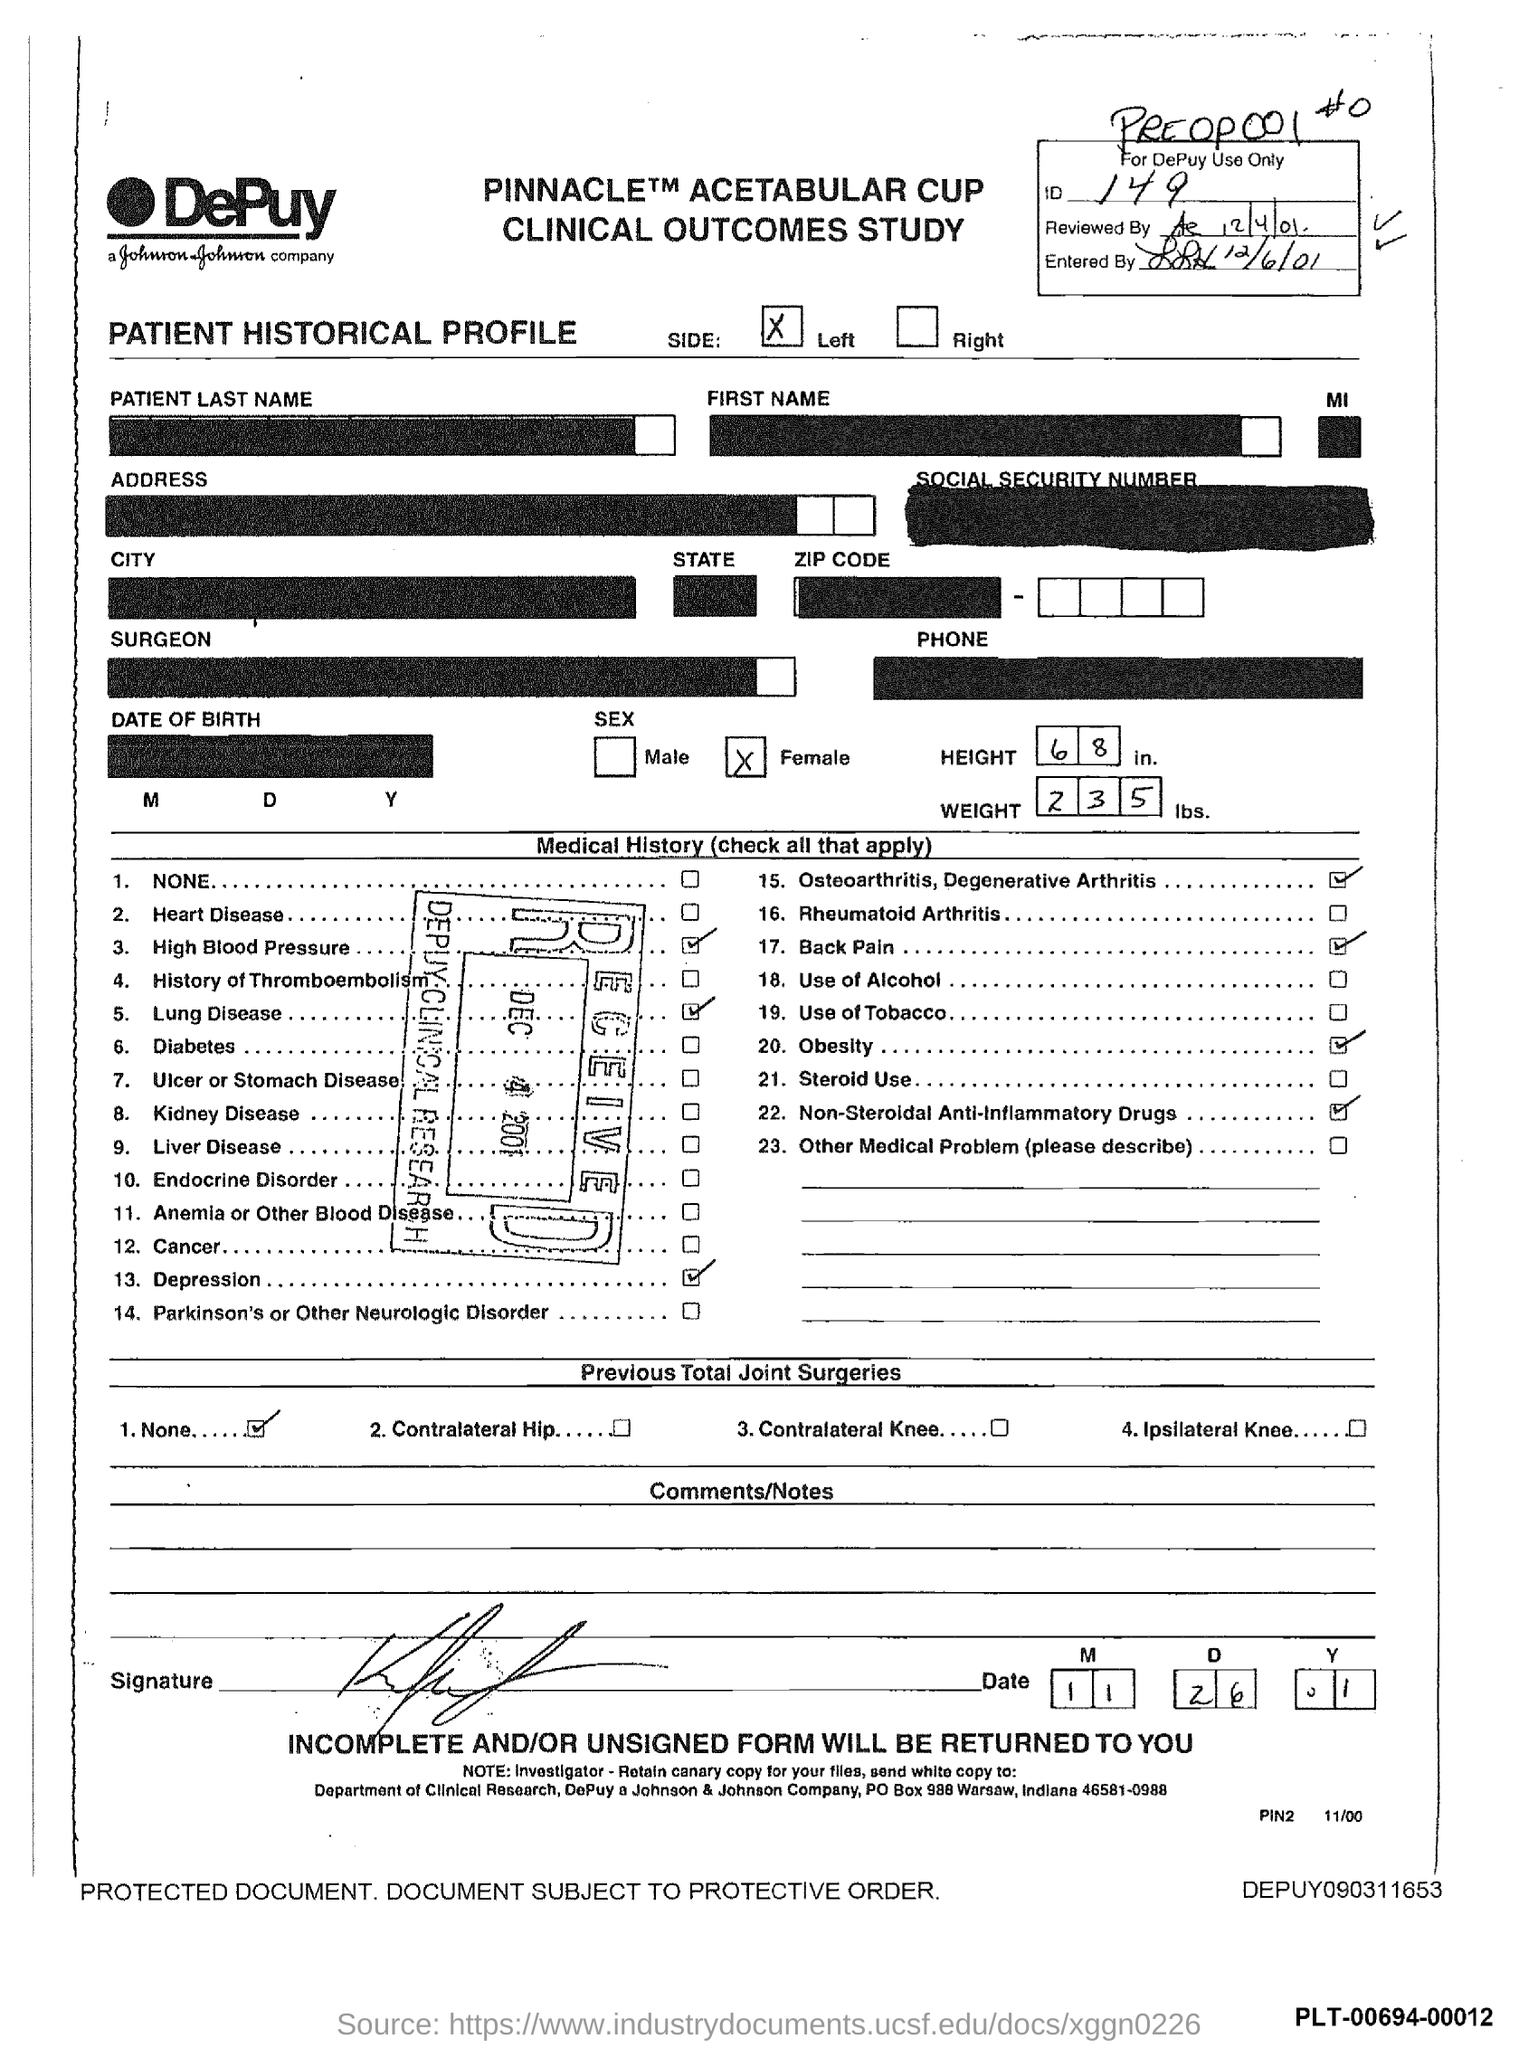What is the ID number?
Provide a short and direct response. 149. What is the reviewed date?
Provide a succinct answer. 12/4/01. What is the height of the patient?
Offer a terse response. 68. What is the weight of the patient?
Make the answer very short. 235 lbs. What is the date mentioned on the recieved stamp?
Keep it short and to the point. DEC 4 2001. Is the patient male or female?
Your answer should be compact. Female. 